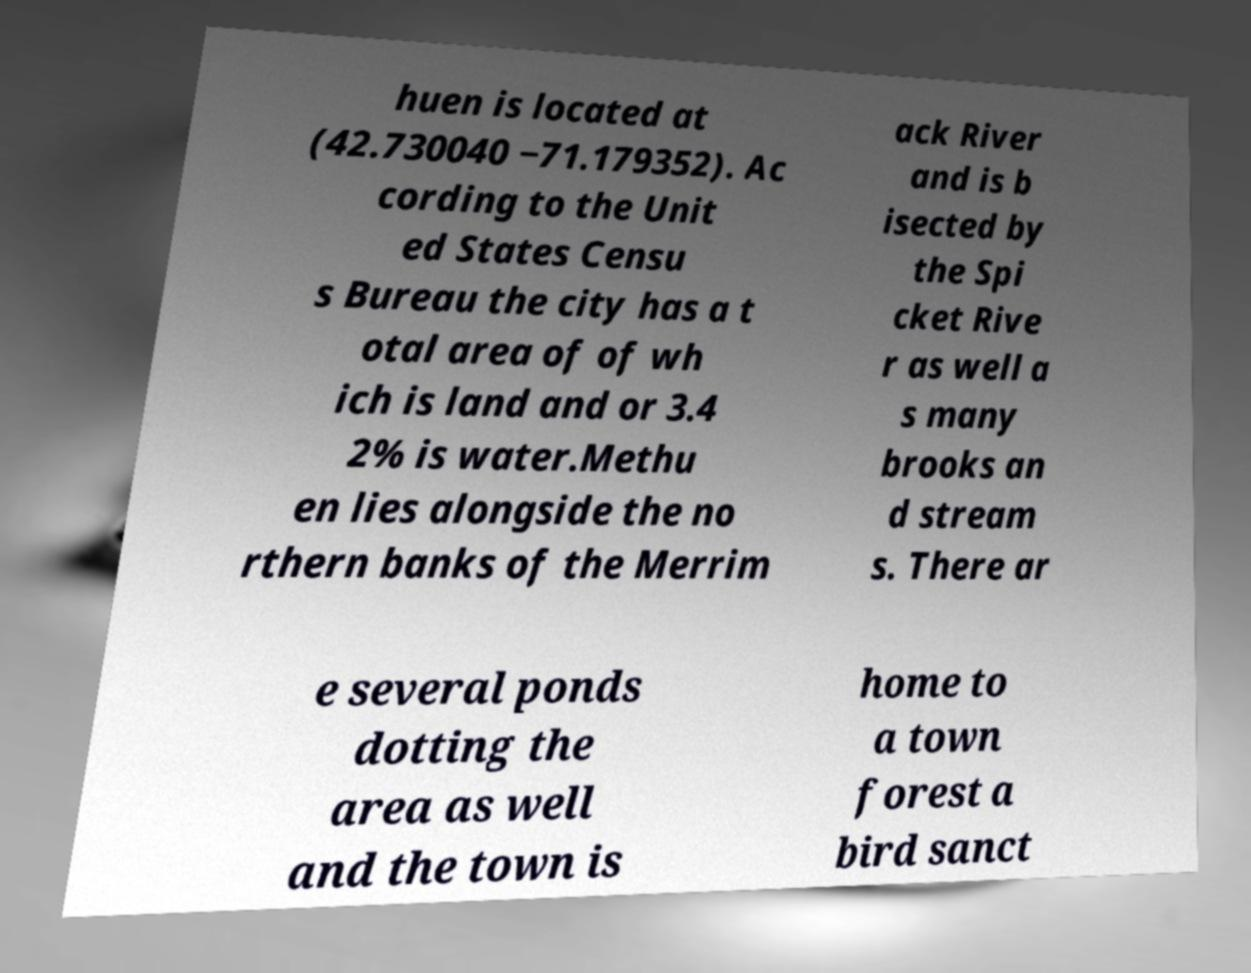Can you accurately transcribe the text from the provided image for me? huen is located at (42.730040 −71.179352). Ac cording to the Unit ed States Censu s Bureau the city has a t otal area of of wh ich is land and or 3.4 2% is water.Methu en lies alongside the no rthern banks of the Merrim ack River and is b isected by the Spi cket Rive r as well a s many brooks an d stream s. There ar e several ponds dotting the area as well and the town is home to a town forest a bird sanct 